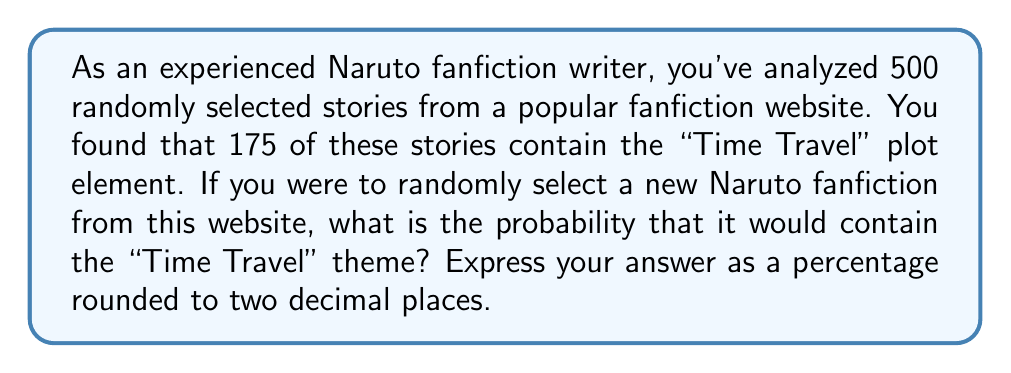What is the answer to this math problem? To solve this problem, we'll use the concept of relative frequency as an estimate for probability. Here's the step-by-step solution:

1) First, let's define our variables:
   $n$ = total number of fanfictions analyzed = 500
   $x$ = number of fanfictions containing "Time Travel" theme = 175

2) The relative frequency, which estimates the probability, is calculated as:

   $$P(\text{Time Travel}) = \frac{\text{Number of favorable outcomes}}{\text{Total number of outcomes}} = \frac{x}{n}$$

3) Substituting our values:

   $$P(\text{Time Travel}) = \frac{175}{500}$$

4) Simplify the fraction:

   $$P(\text{Time Travel}) = 0.35$$

5) Convert to a percentage:

   $$P(\text{Time Travel}) = 0.35 \times 100\% = 35\%$$

6) The question asks for the result rounded to two decimal places, but 35.00% is already in that form.

Therefore, based on the sample, there is a 35.00% chance that a randomly selected Naruto fanfiction from this website would contain the "Time Travel" theme.
Answer: 35.00% 